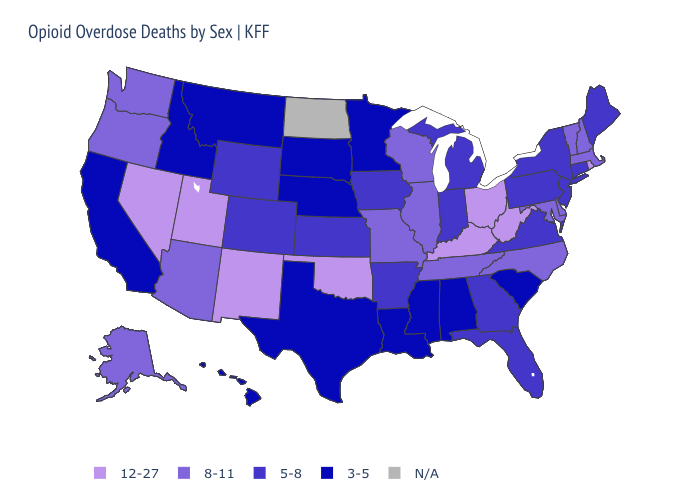What is the value of Georgia?
Give a very brief answer. 5-8. Name the states that have a value in the range 5-8?
Concise answer only. Arkansas, Colorado, Connecticut, Florida, Georgia, Indiana, Iowa, Kansas, Maine, Michigan, New Jersey, New York, Pennsylvania, Virginia, Wyoming. Name the states that have a value in the range 3-5?
Answer briefly. Alabama, California, Hawaii, Idaho, Louisiana, Minnesota, Mississippi, Montana, Nebraska, South Carolina, South Dakota, Texas. Which states have the highest value in the USA?
Give a very brief answer. Kentucky, Nevada, New Mexico, Ohio, Oklahoma, Rhode Island, Utah, West Virginia. Does Vermont have the lowest value in the Northeast?
Quick response, please. No. What is the value of New Jersey?
Write a very short answer. 5-8. What is the highest value in the Northeast ?
Give a very brief answer. 12-27. What is the lowest value in the USA?
Give a very brief answer. 3-5. Name the states that have a value in the range 5-8?
Concise answer only. Arkansas, Colorado, Connecticut, Florida, Georgia, Indiana, Iowa, Kansas, Maine, Michigan, New Jersey, New York, Pennsylvania, Virginia, Wyoming. What is the lowest value in the MidWest?
Be succinct. 3-5. Does Kansas have the lowest value in the MidWest?
Be succinct. No. What is the value of Wisconsin?
Keep it brief. 8-11. What is the value of Alabama?
Keep it brief. 3-5. 